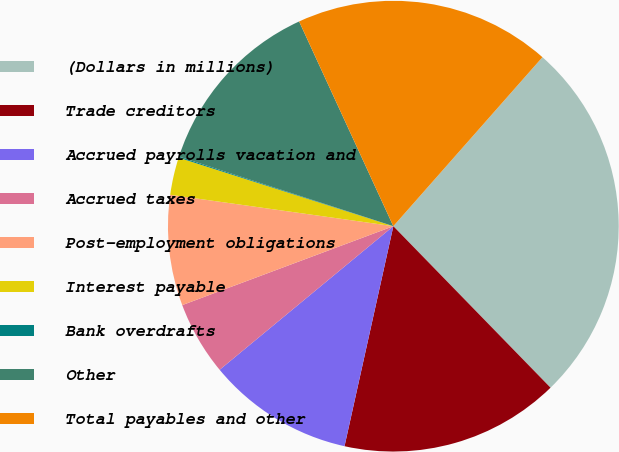Convert chart to OTSL. <chart><loc_0><loc_0><loc_500><loc_500><pie_chart><fcel>(Dollars in millions)<fcel>Trade creditors<fcel>Accrued payrolls vacation and<fcel>Accrued taxes<fcel>Post-employment obligations<fcel>Interest payable<fcel>Bank overdrafts<fcel>Other<fcel>Total payables and other<nl><fcel>26.21%<fcel>15.76%<fcel>10.53%<fcel>5.3%<fcel>7.92%<fcel>2.69%<fcel>0.08%<fcel>13.14%<fcel>18.37%<nl></chart> 